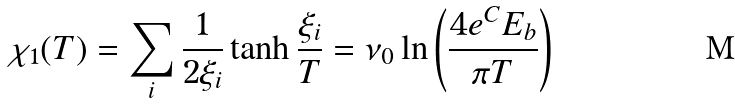<formula> <loc_0><loc_0><loc_500><loc_500>\chi _ { 1 } ( T ) = \sum _ { i } \frac { 1 } { 2 \xi _ { i } } \tanh \frac { \xi _ { i } } { T } = \nu _ { 0 } \ln \left ( \frac { 4 e ^ { C } E _ { b } } { \pi T } \right )</formula> 